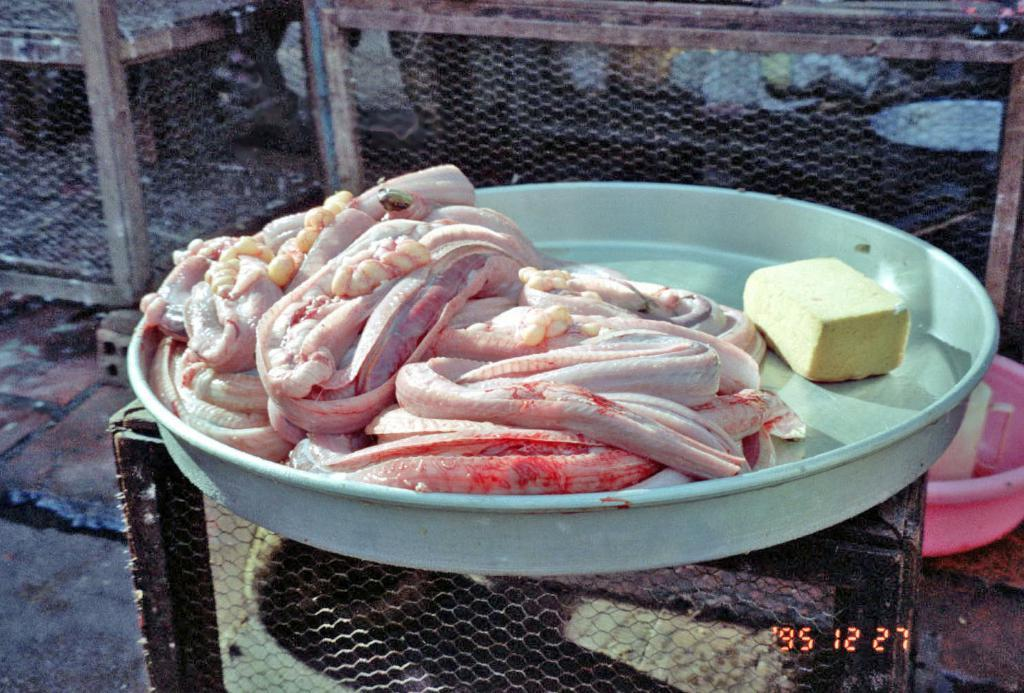What type of food is present in the image? There is meat in the image. What are the containers used for in the image? The containers are present in the image, but their purpose is not specified. What material is used to create a barrier or structure in the image? There is mesh in the image, which is used as a barrier or structure. Can you hear someone coughing in the image? There is no auditory information in the image, so it is not possible to determine if someone is coughing. 